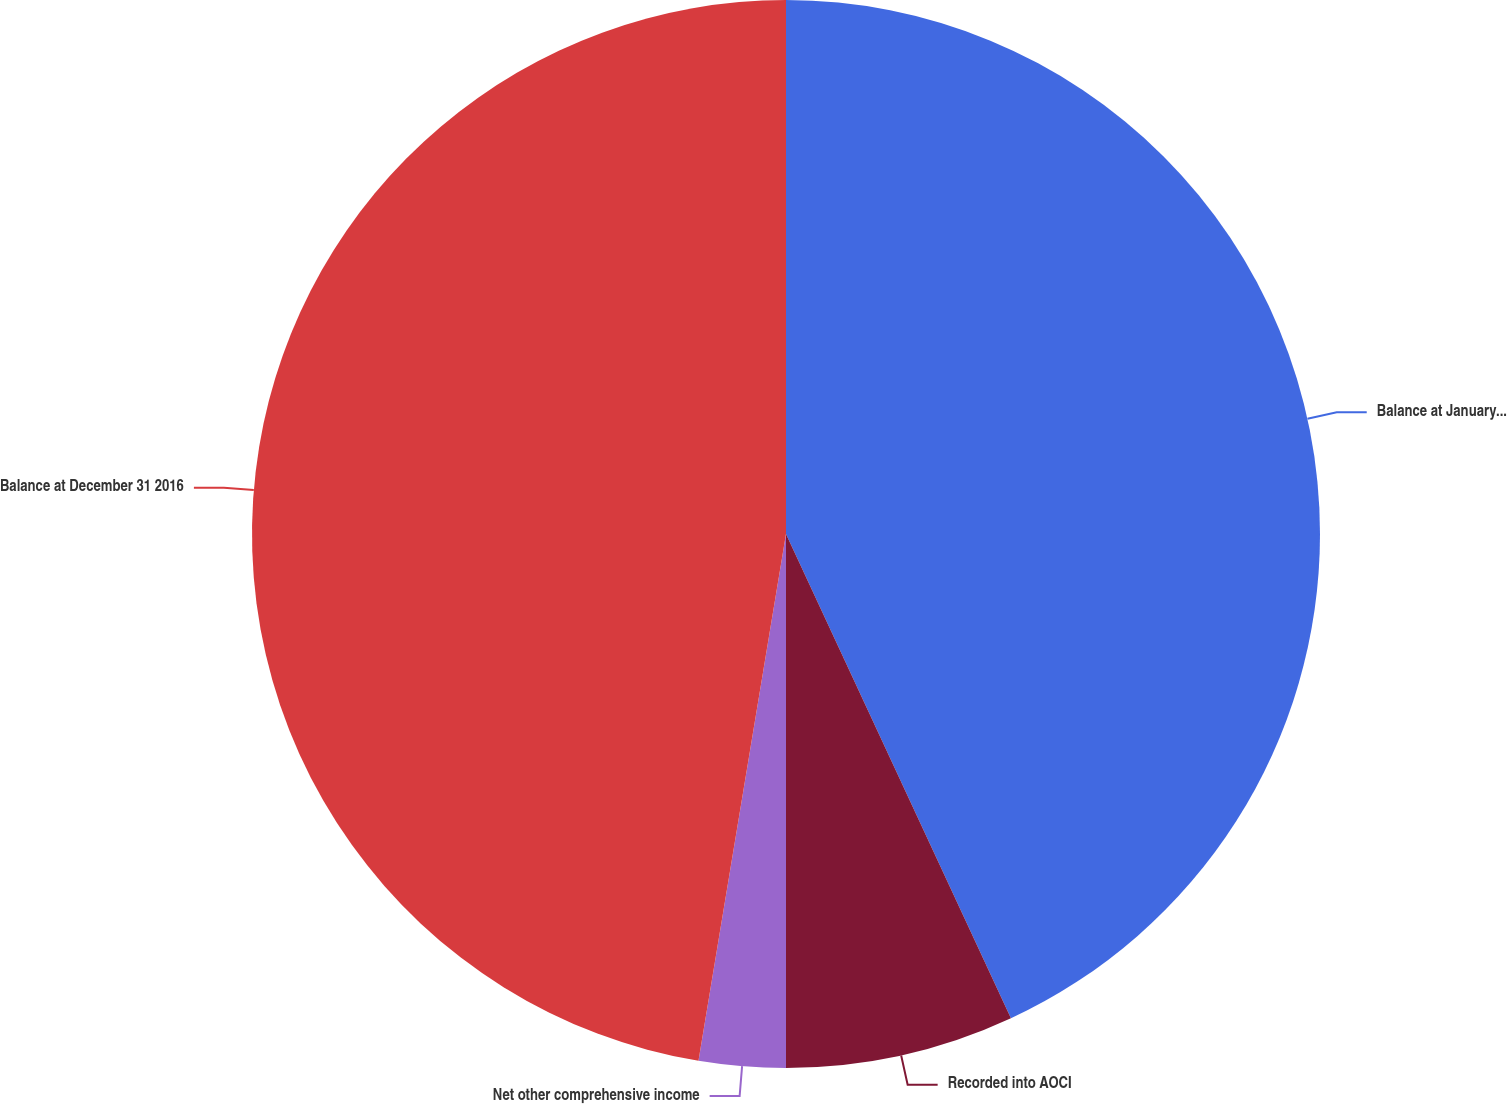Convert chart. <chart><loc_0><loc_0><loc_500><loc_500><pie_chart><fcel>Balance at January 1 2016<fcel>Recorded into AOCI<fcel>Net other comprehensive income<fcel>Balance at December 31 2016<nl><fcel>43.08%<fcel>6.92%<fcel>2.62%<fcel>47.38%<nl></chart> 